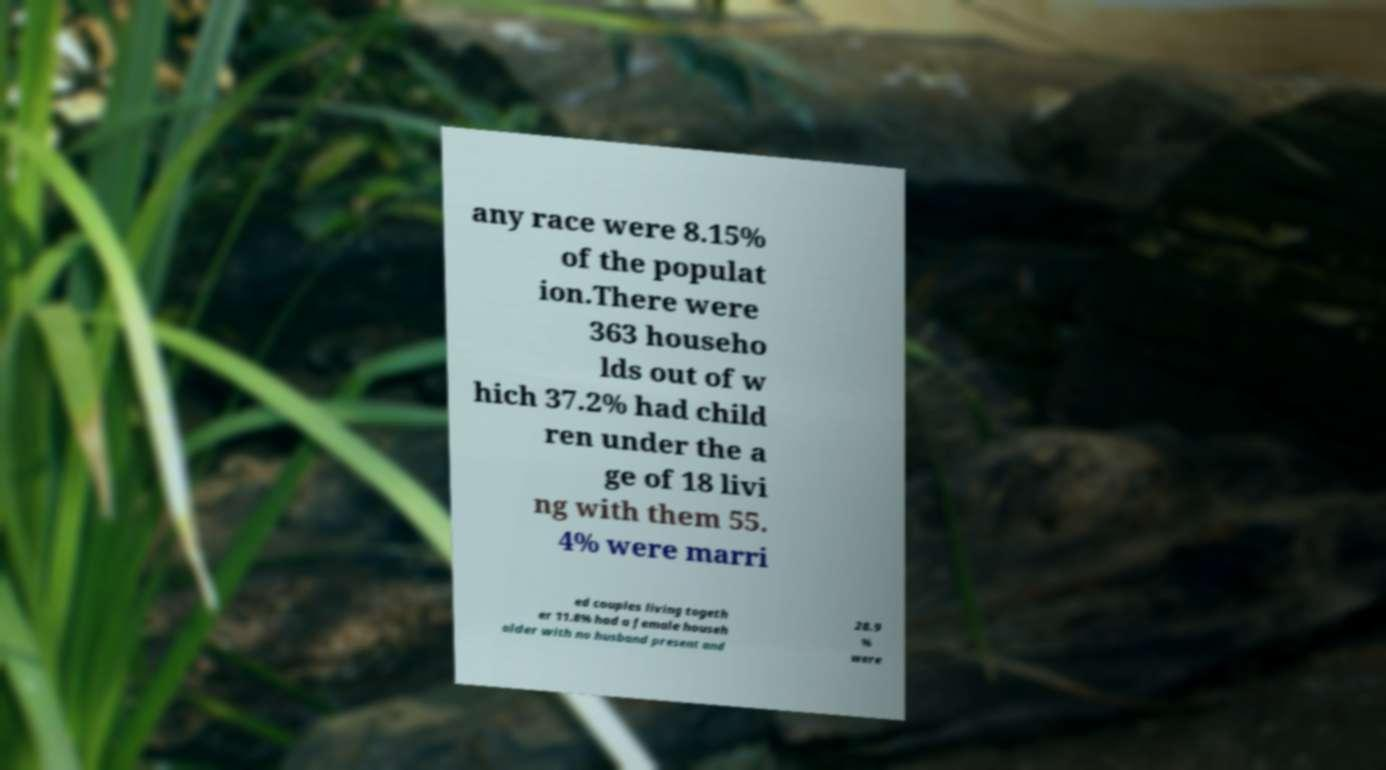Please identify and transcribe the text found in this image. any race were 8.15% of the populat ion.There were 363 househo lds out of w hich 37.2% had child ren under the a ge of 18 livi ng with them 55. 4% were marri ed couples living togeth er 11.8% had a female househ older with no husband present and 28.9 % were 